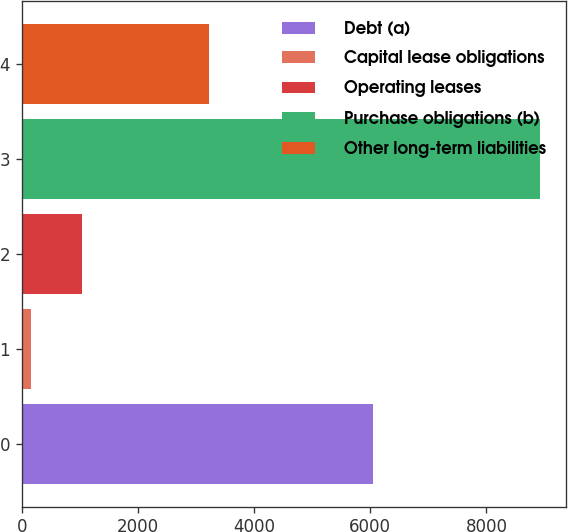Convert chart. <chart><loc_0><loc_0><loc_500><loc_500><bar_chart><fcel>Debt (a)<fcel>Capital lease obligations<fcel>Operating leases<fcel>Purchase obligations (b)<fcel>Other long-term liabilities<nl><fcel>6040<fcel>162<fcel>1037.6<fcel>8918<fcel>3215<nl></chart> 